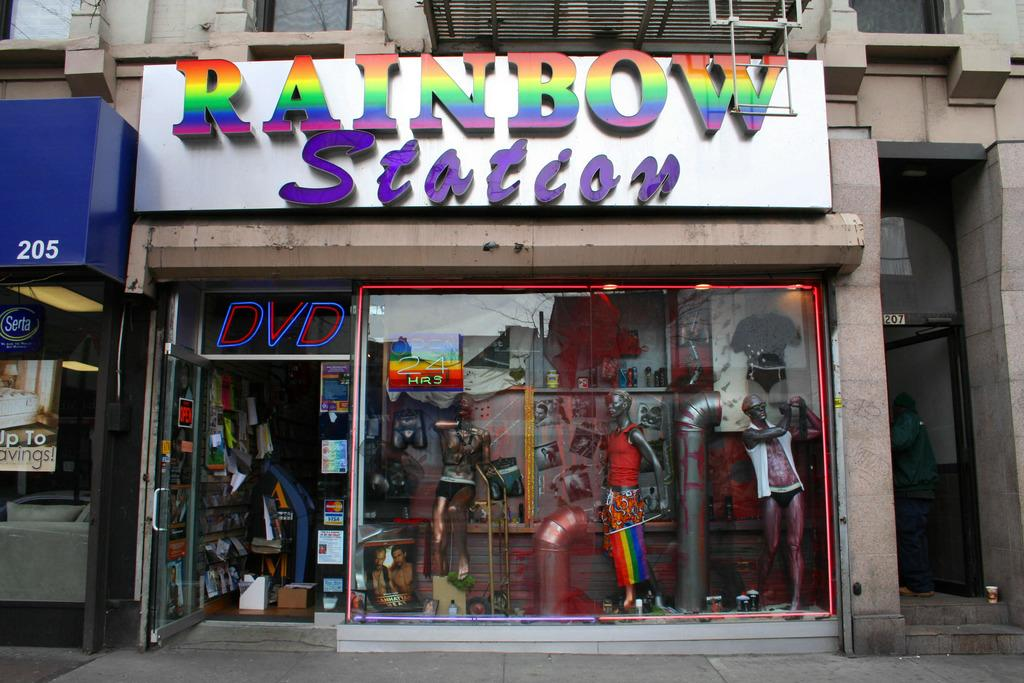Provide a one-sentence caption for the provided image. The front of a the store named Rainbow Station showing the display window. 